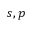Convert formula to latex. <formula><loc_0><loc_0><loc_500><loc_500>s , p</formula> 